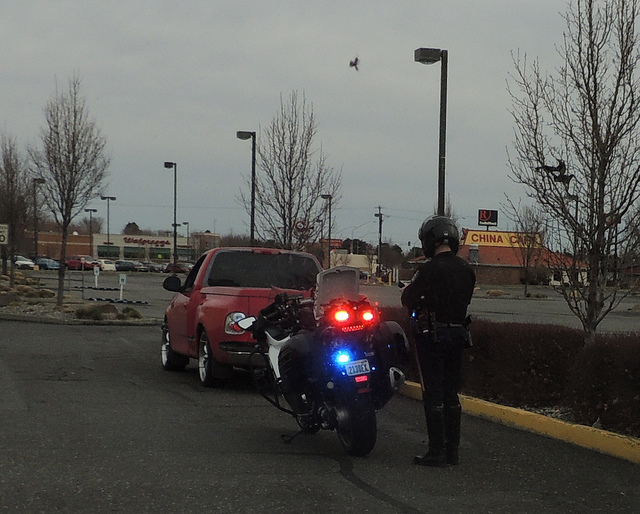Extract all visible text content from this image. CHINA C 